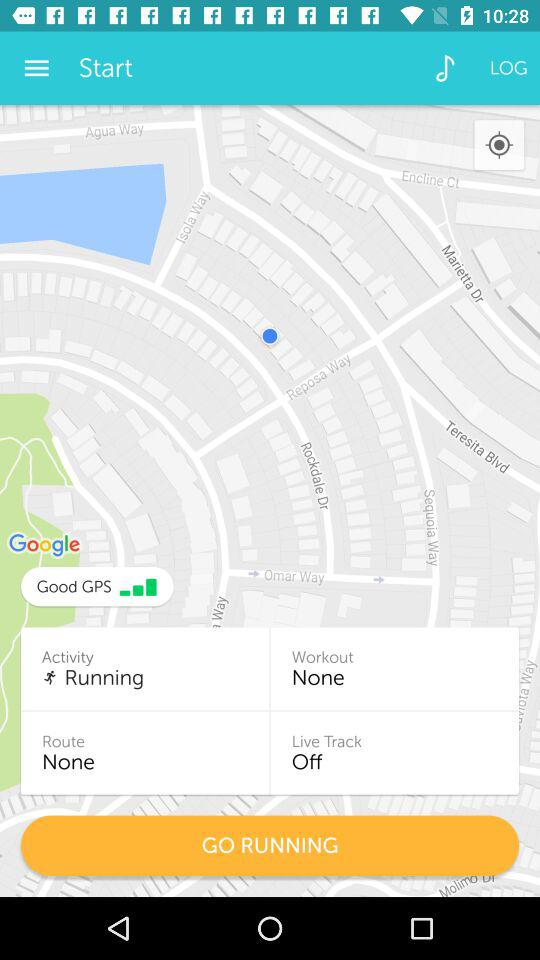What is the route? The route is "None". 